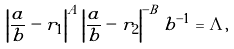<formula> <loc_0><loc_0><loc_500><loc_500>\left | \frac { a } { b } - r _ { 1 } \right | ^ { A } \left | \frac { a } { b } - r _ { 2 } \right | ^ { - B } b ^ { - 1 } = \Lambda ,</formula> 